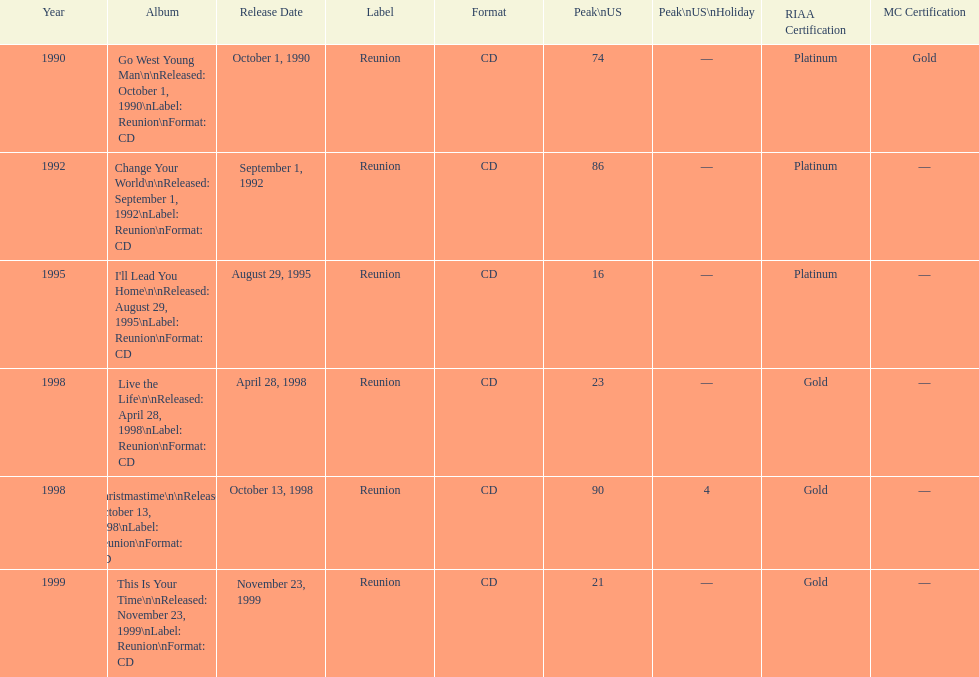Riaa: gold is only one of the certifications, but what is the other? Platinum. 